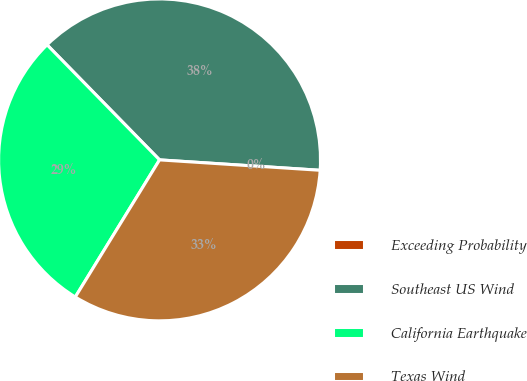Convert chart. <chart><loc_0><loc_0><loc_500><loc_500><pie_chart><fcel>Exceeding Probability<fcel>Southeast US Wind<fcel>California Earthquake<fcel>Texas Wind<nl><fcel>0.0%<fcel>38.35%<fcel>28.91%<fcel>32.74%<nl></chart> 